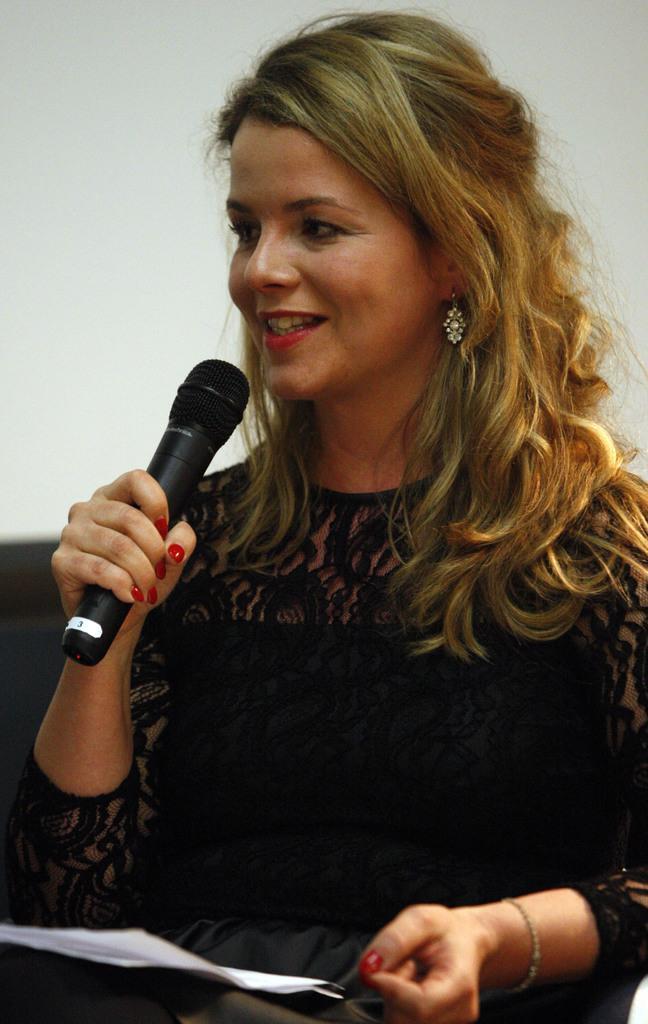Describe this image in one or two sentences. In this picture we can a beautiful women wearing a black gown and setting on the chair, holding a microphone in her left hand and a piece of paper on her lap, seeing and smelling towards the camera 